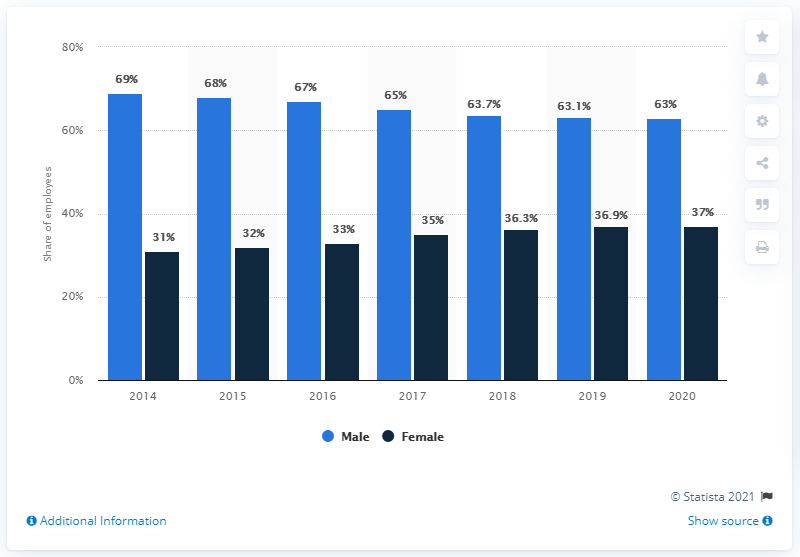Identify some key points in this picture. In the year 2020, the difference between males and females in terms of Facebook usage was minimized. In 2017, 65% of males used Facebook. 